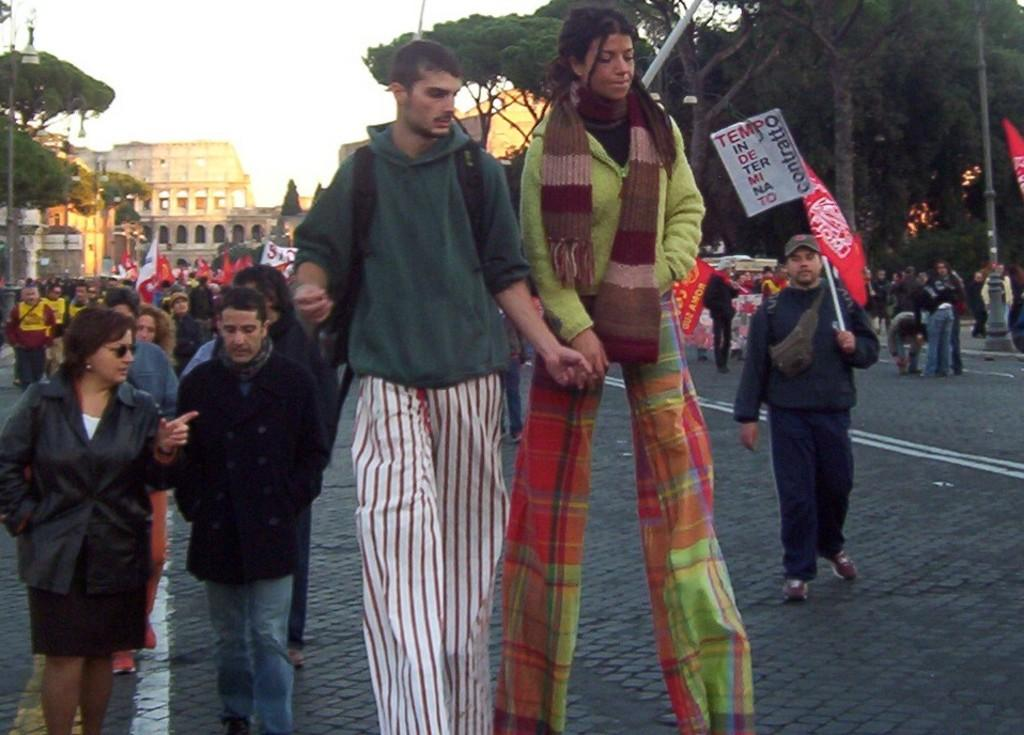What is happening on the road in the image? There is a crowd on the road in the image. What can be seen in the background of the image? Trees and buildings are visible in the background of the image. What is visible at the top of the image? The sky is visible at the top of the image. What type of pencil can be seen in the image? There is no pencil present in the image. How many eggs are visible in the image? There are no eggs visible in the image. 